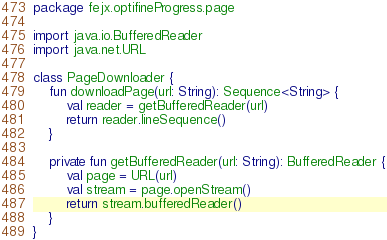Convert code to text. <code><loc_0><loc_0><loc_500><loc_500><_Kotlin_>package fejx.optifineProgress.page

import java.io.BufferedReader
import java.net.URL

class PageDownloader {
	fun downloadPage(url: String): Sequence<String> {
		val reader = getBufferedReader(url)
		return reader.lineSequence()
	}

	private fun getBufferedReader(url: String): BufferedReader {
		val page = URL(url)
		val stream = page.openStream()
		return stream.bufferedReader()
	}
}
</code> 